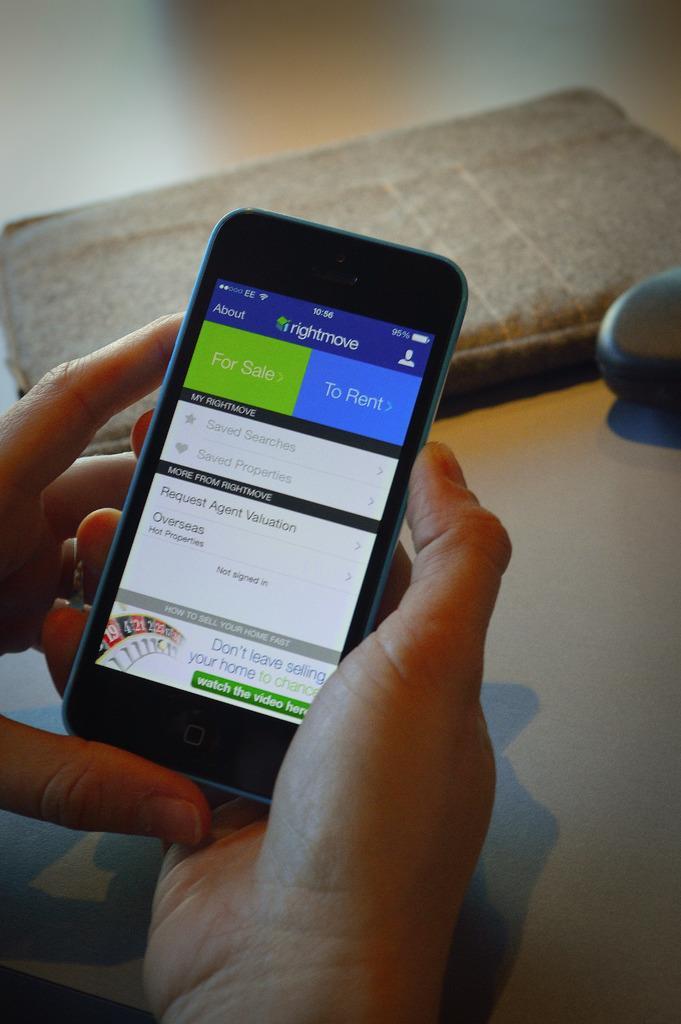How would you summarize this image in a sentence or two? In this image we can see person´s hands holding a cellphone and there are some objects on the floor. 